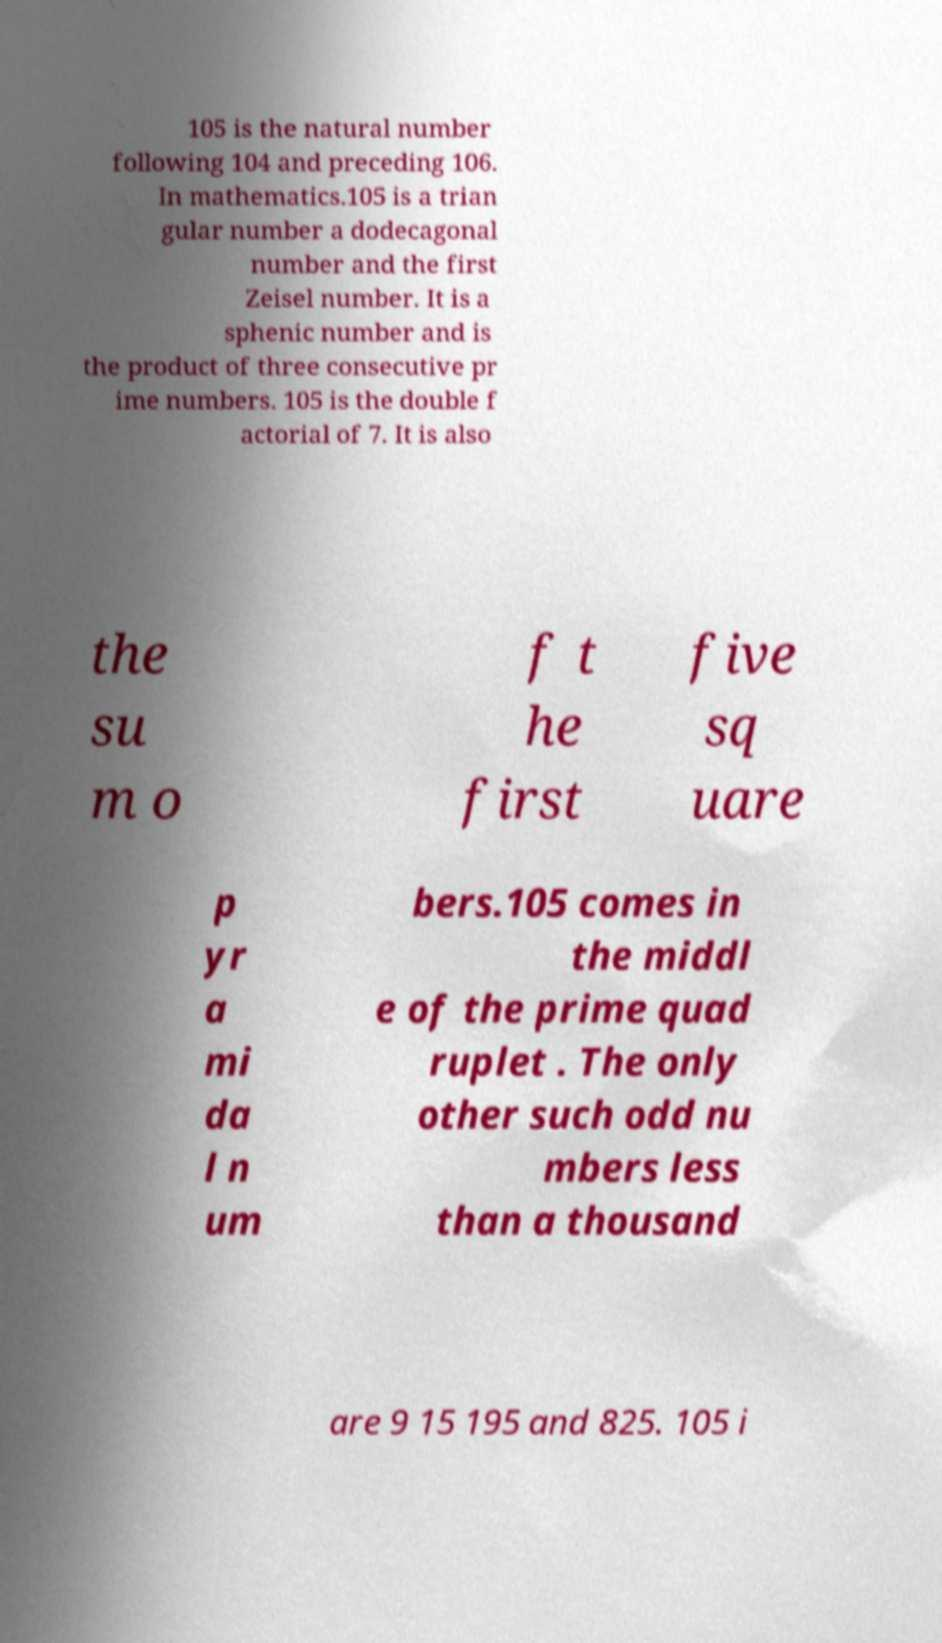What messages or text are displayed in this image? I need them in a readable, typed format. 105 is the natural number following 104 and preceding 106. In mathematics.105 is a trian gular number a dodecagonal number and the first Zeisel number. It is a sphenic number and is the product of three consecutive pr ime numbers. 105 is the double f actorial of 7. It is also the su m o f t he first five sq uare p yr a mi da l n um bers.105 comes in the middl e of the prime quad ruplet . The only other such odd nu mbers less than a thousand are 9 15 195 and 825. 105 i 